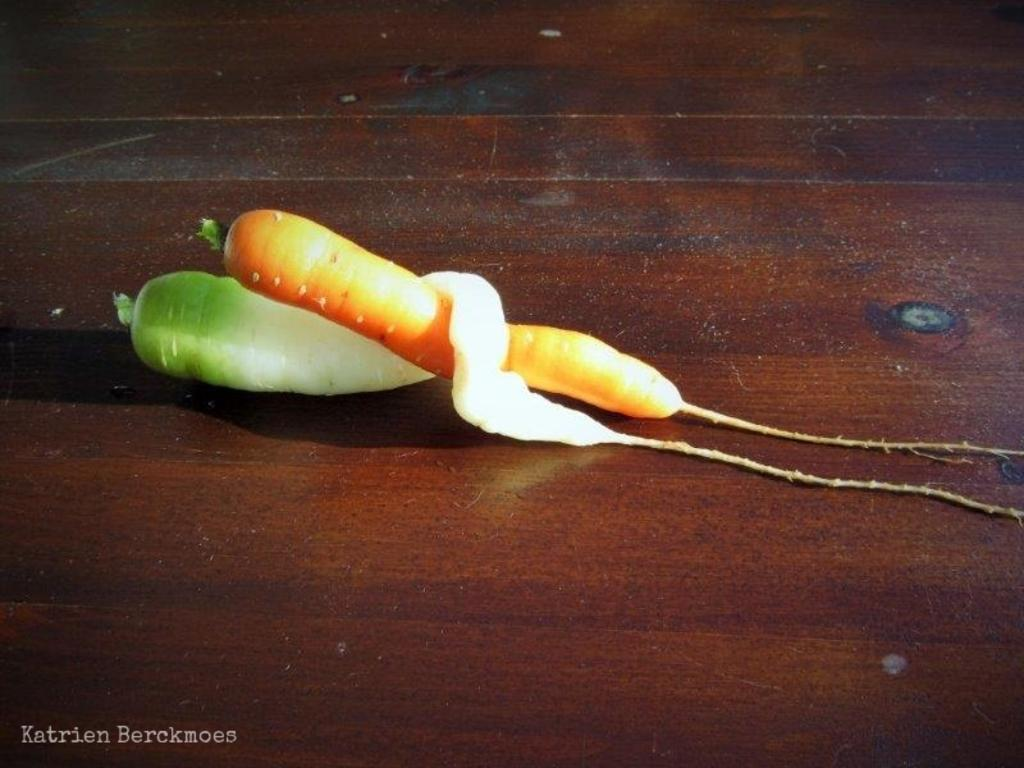What vegetables can be seen in the image? There is a carrot and a radish in the image. Where are the vegetables located? Both the carrot and radish are on a table. Is there any text present in the image? Yes, there is some text at the bottom of the image. What type of toothpaste is being squeezed out of the carrot in the image? There is no toothpaste present in the image, and the carrot is not being squeezed. 